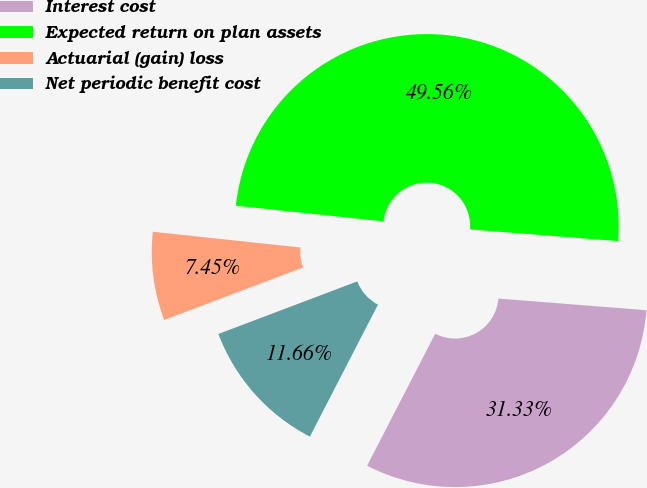Convert chart. <chart><loc_0><loc_0><loc_500><loc_500><pie_chart><fcel>Interest cost<fcel>Expected return on plan assets<fcel>Actuarial (gain) loss<fcel>Net periodic benefit cost<nl><fcel>31.33%<fcel>49.56%<fcel>7.45%<fcel>11.66%<nl></chart> 